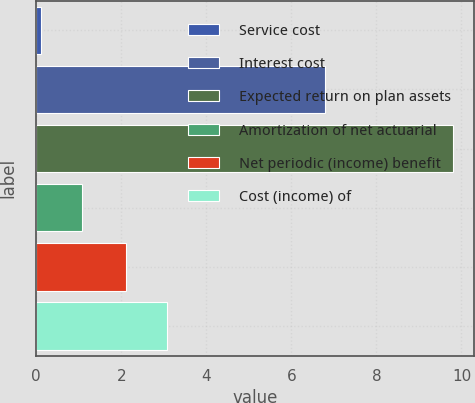Convert chart. <chart><loc_0><loc_0><loc_500><loc_500><bar_chart><fcel>Service cost<fcel>Interest cost<fcel>Expected return on plan assets<fcel>Amortization of net actuarial<fcel>Net periodic (income) benefit<fcel>Cost (income) of<nl><fcel>0.1<fcel>6.8<fcel>9.8<fcel>1.07<fcel>2.1<fcel>3.07<nl></chart> 